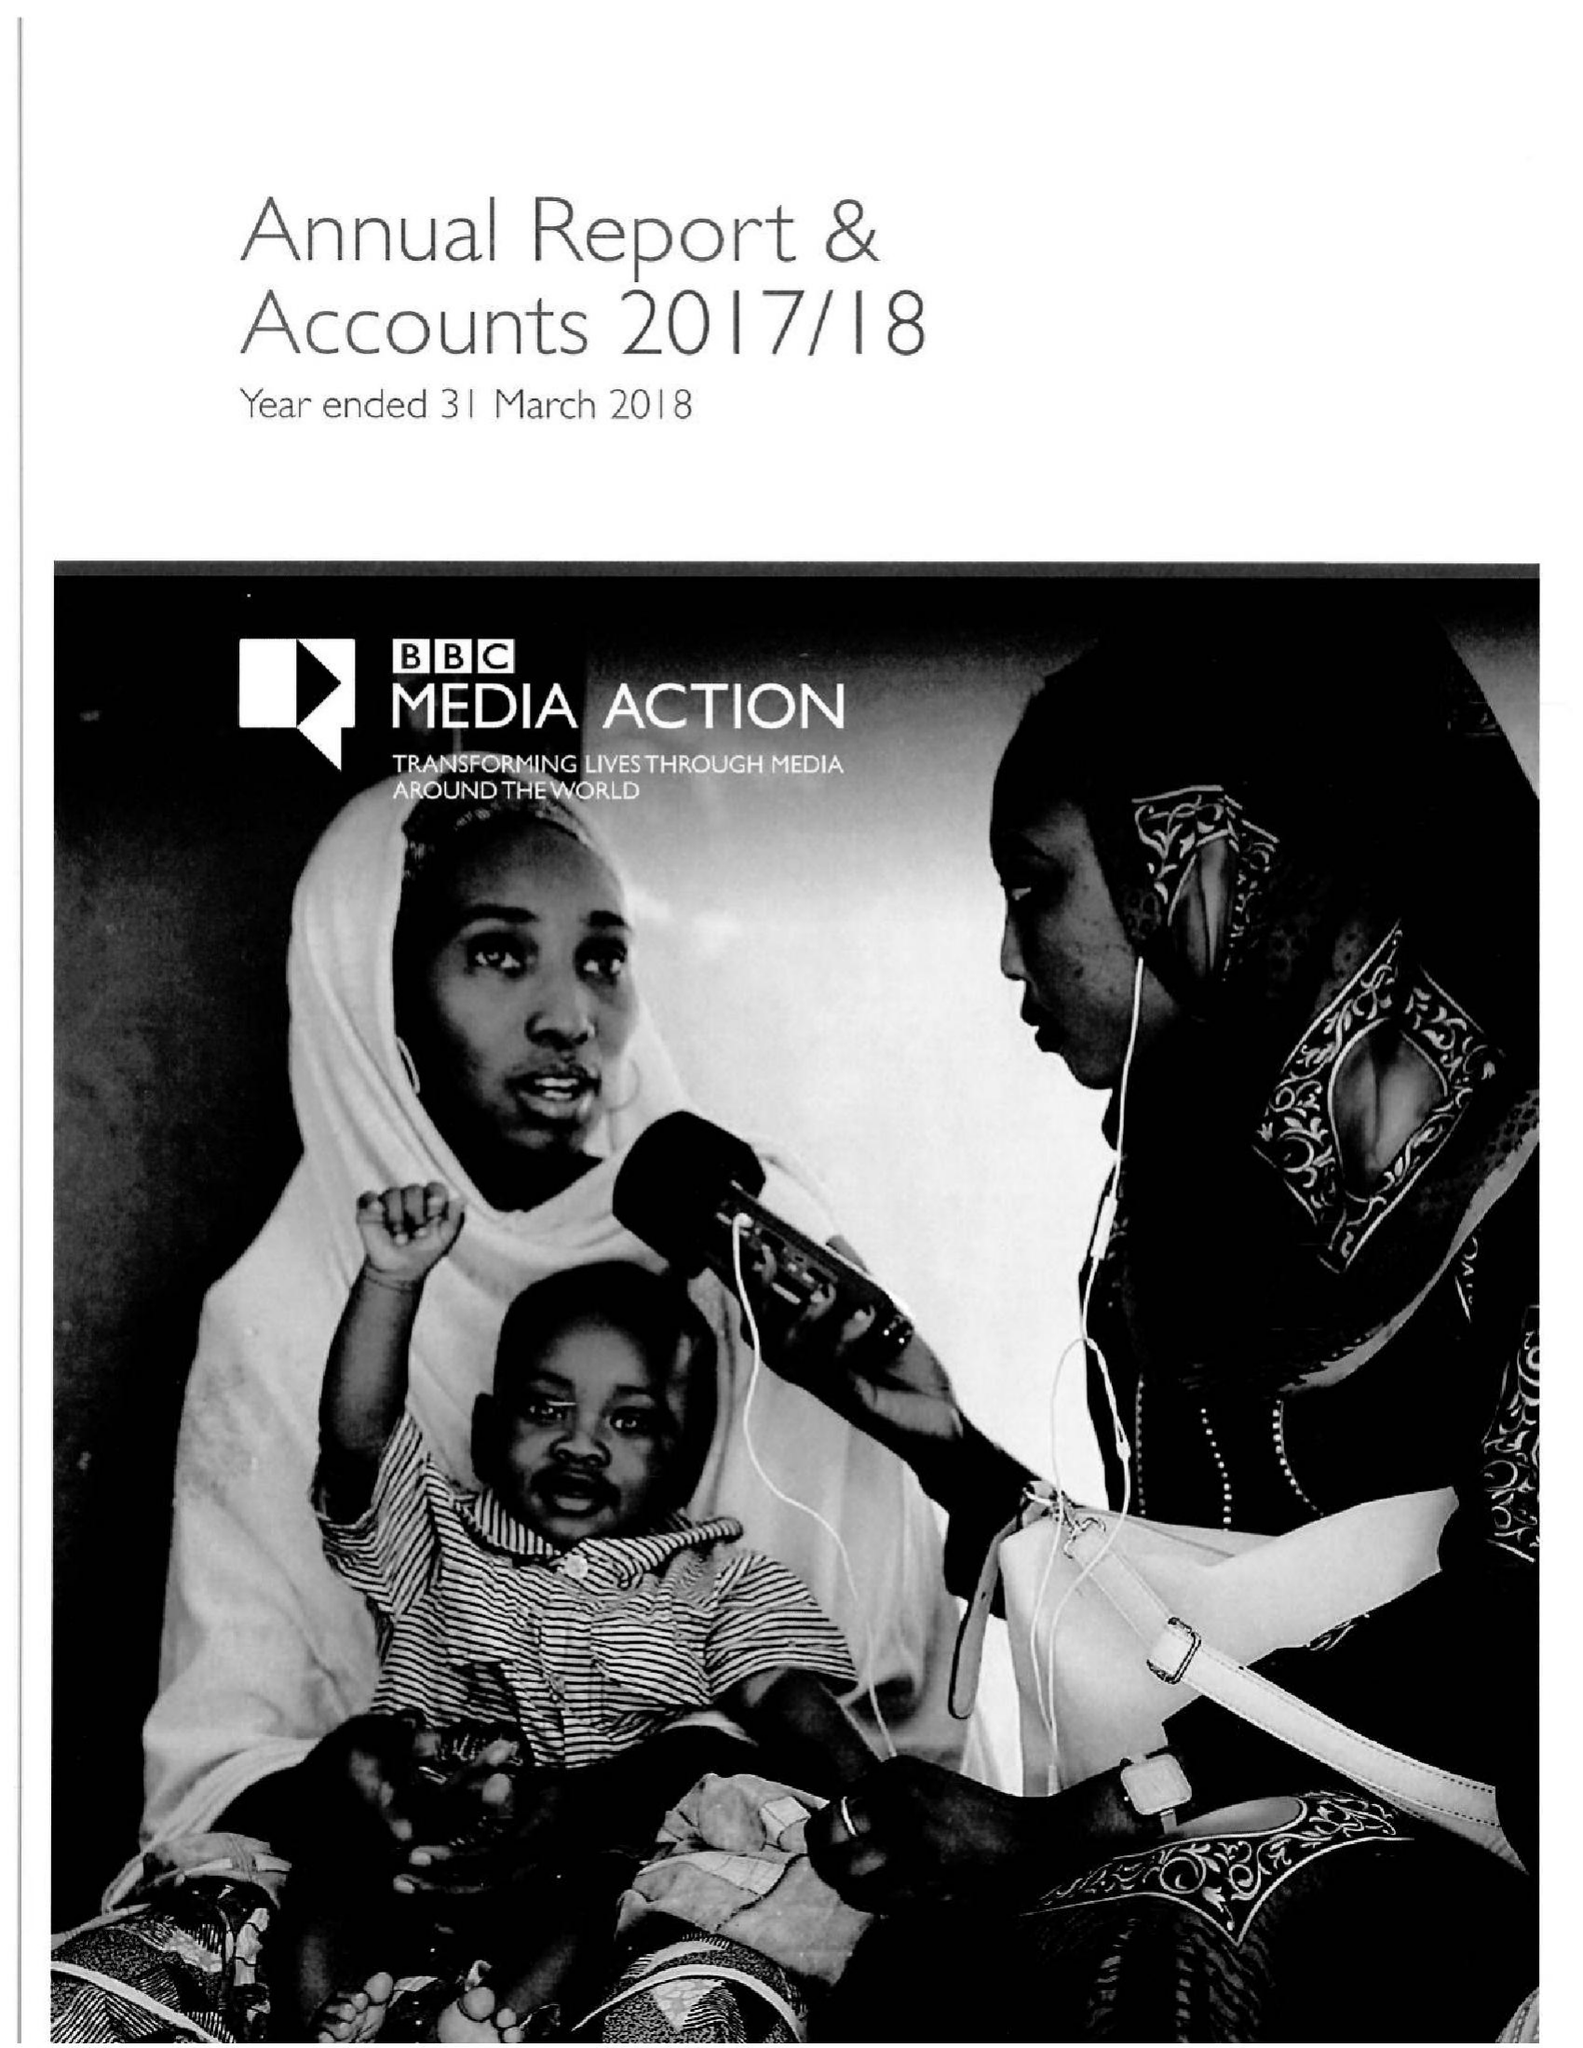What is the value for the charity_number?
Answer the question using a single word or phrase. 1076235 